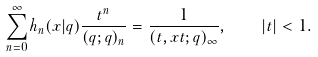<formula> <loc_0><loc_0><loc_500><loc_500>\sum _ { n = 0 } ^ { \infty } h _ { n } ( x | q ) \frac { t ^ { n } } { ( q ; q ) _ { n } } = \frac { 1 } { ( t , x t ; q ) _ { \infty } } , \quad | t | < 1 .</formula> 